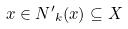<formula> <loc_0><loc_0><loc_500><loc_500>x \in { N ^ { \prime } } _ { k } ( x ) \subseteq X</formula> 